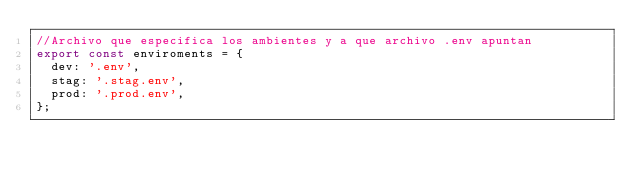<code> <loc_0><loc_0><loc_500><loc_500><_TypeScript_>//Archivo que especifica los ambientes y a que archivo .env apuntan
export const enviroments = {
  dev: '.env',
  stag: '.stag.env',
  prod: '.prod.env',
};
</code> 